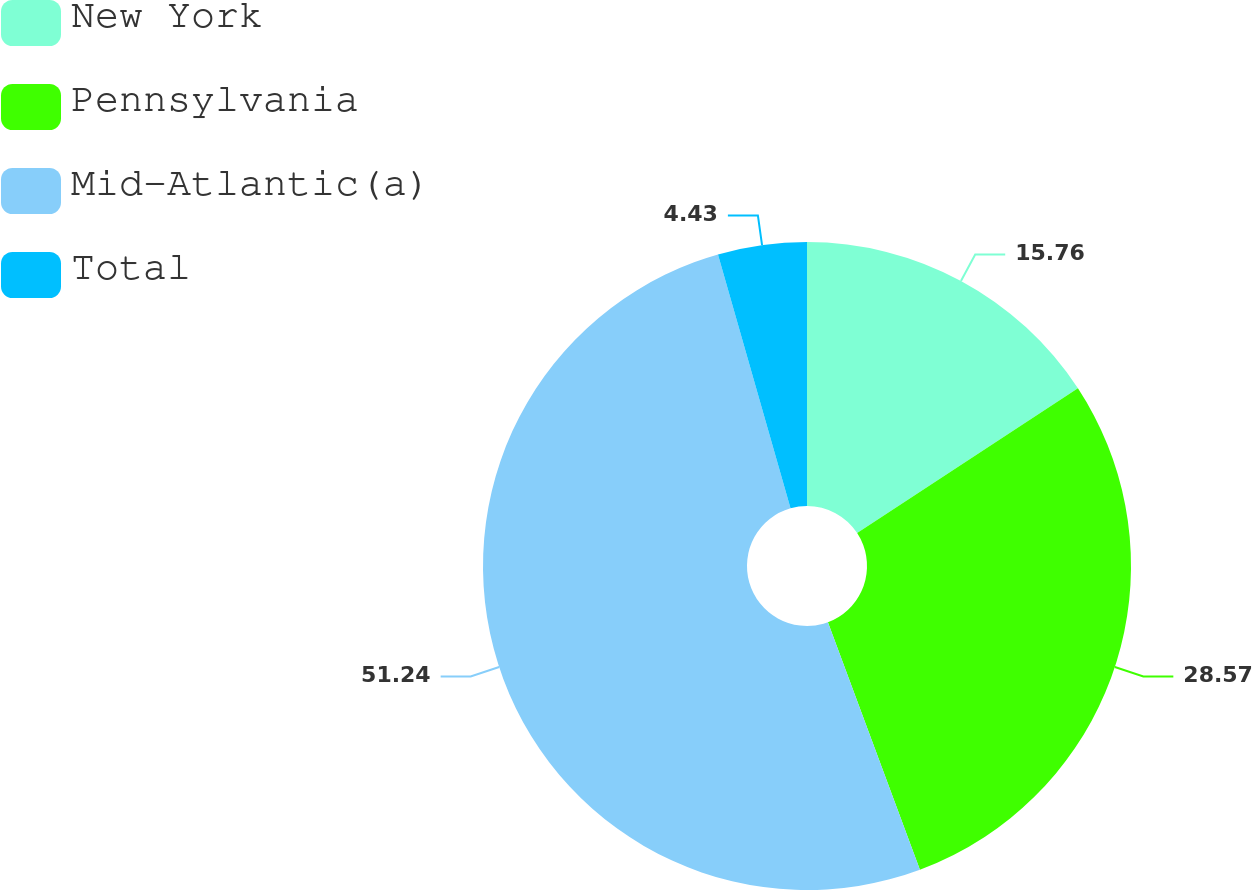Convert chart to OTSL. <chart><loc_0><loc_0><loc_500><loc_500><pie_chart><fcel>New York<fcel>Pennsylvania<fcel>Mid-Atlantic(a)<fcel>Total<nl><fcel>15.76%<fcel>28.57%<fcel>51.23%<fcel>4.43%<nl></chart> 